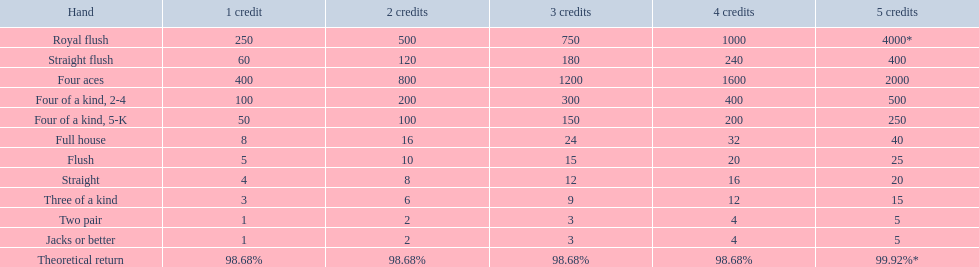What are the components of each hand? Royal flush, Straight flush, Four aces, Four of a kind, 2-4, Four of a kind, 5-K, Full house, Flush, Straight, Three of a kind, Two pair, Jacks or better, Theoretical return. In terms of ranking, do straights or flushes hold a higher position? Flush. 